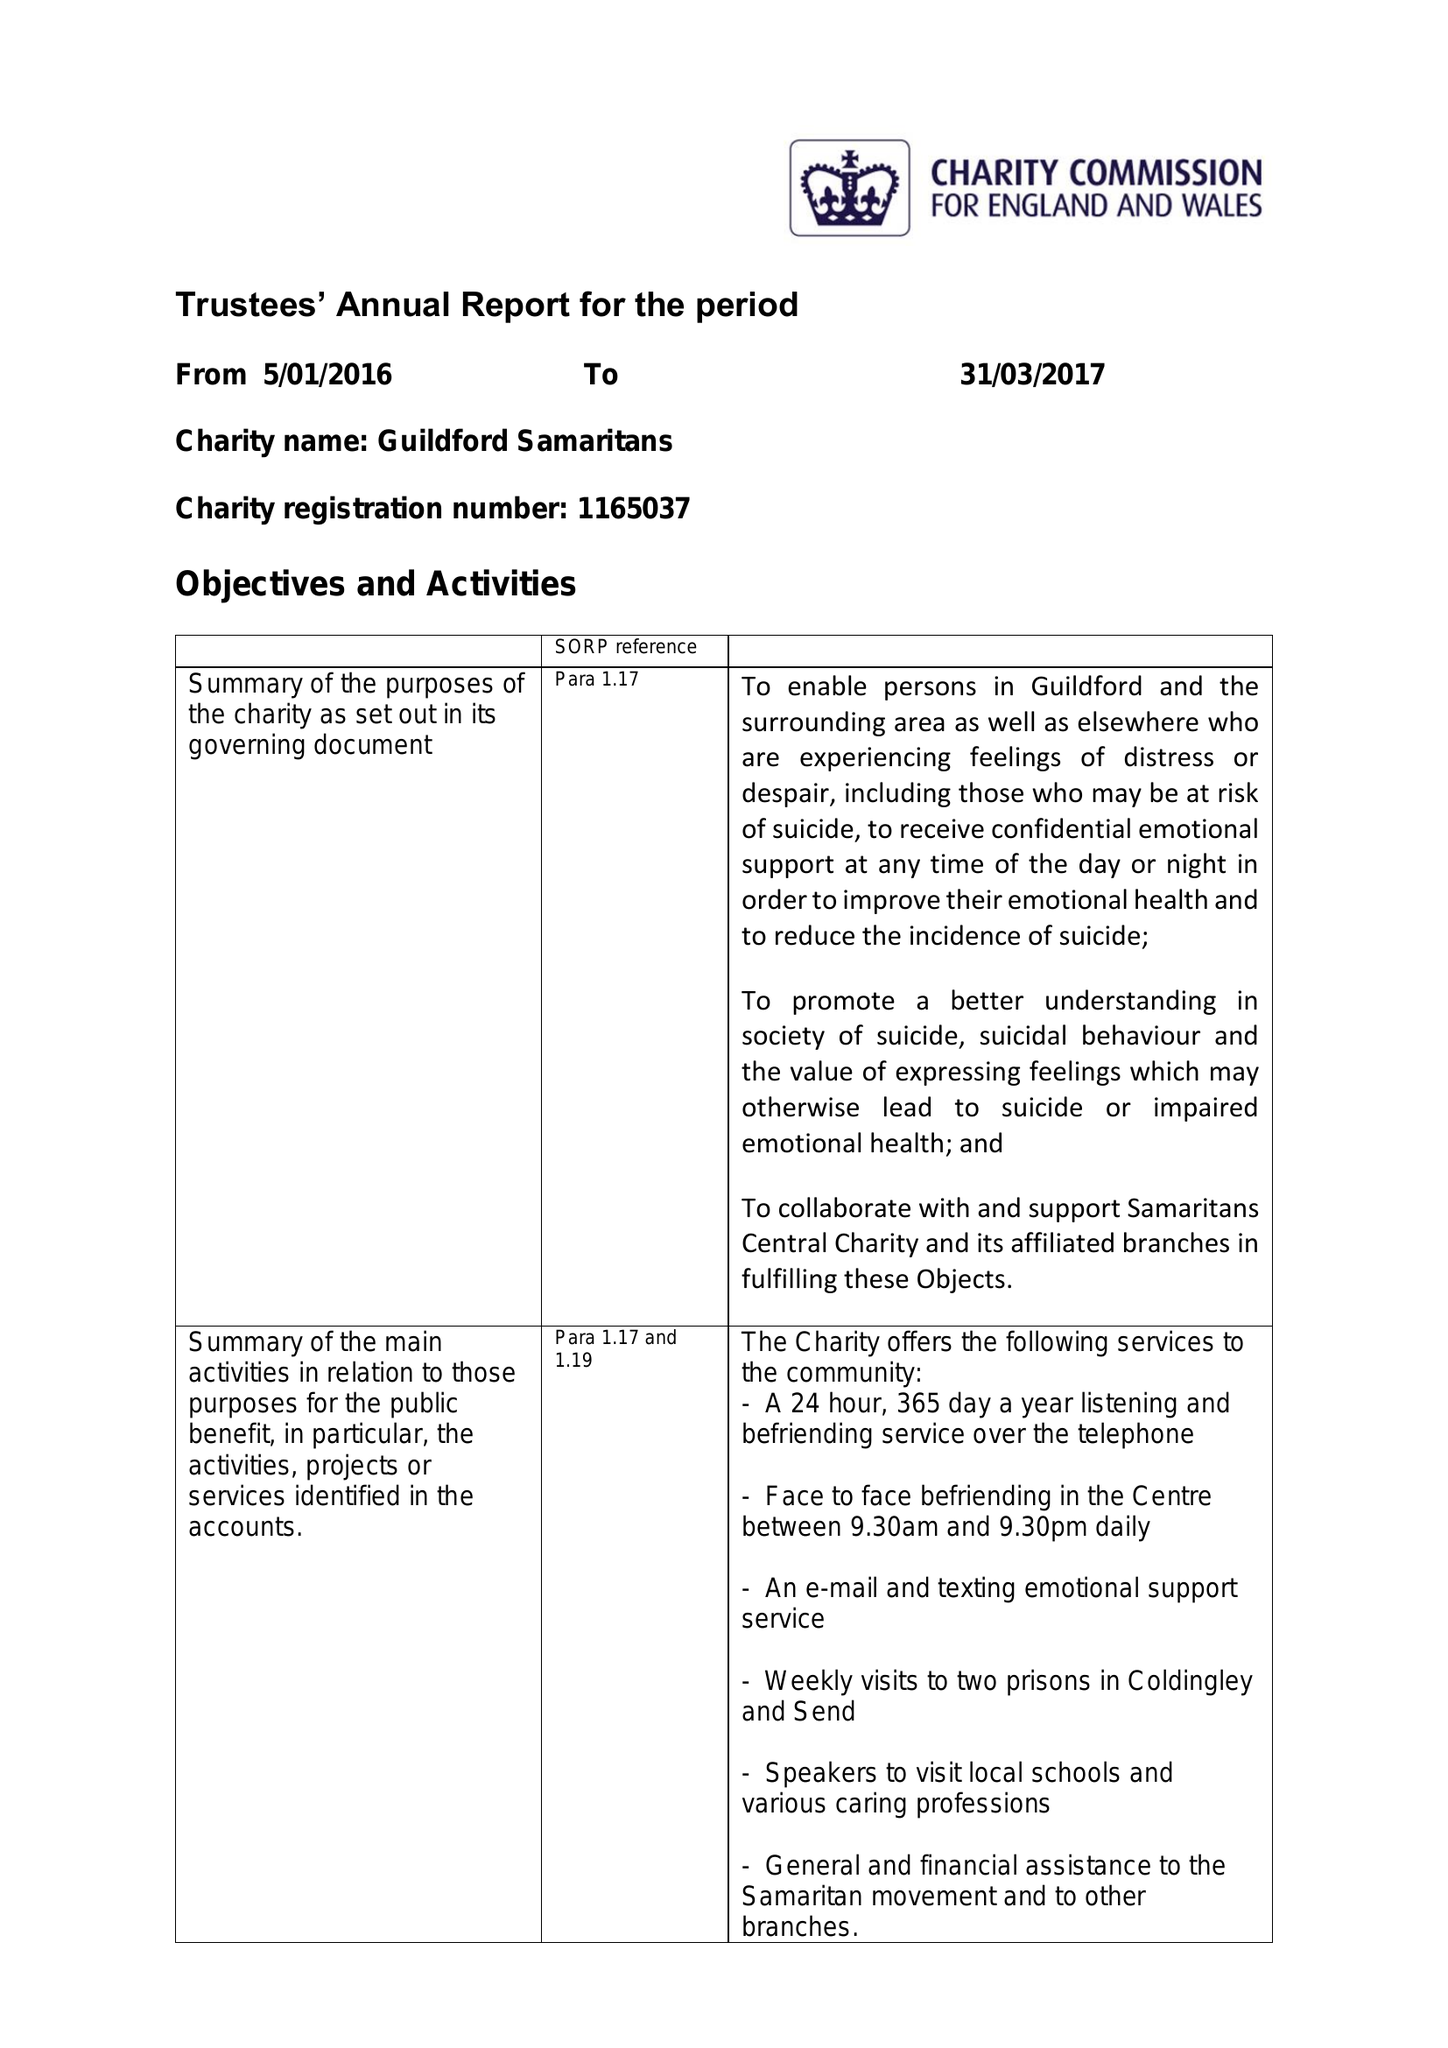What is the value for the report_date?
Answer the question using a single word or phrase. 2017-03-31 